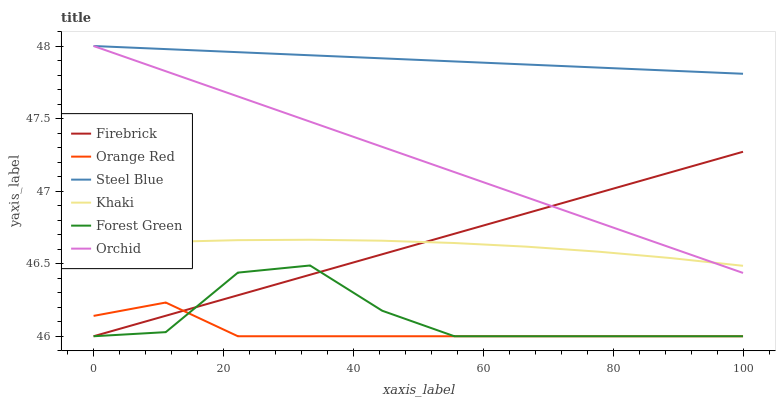Does Orange Red have the minimum area under the curve?
Answer yes or no. Yes. Does Steel Blue have the maximum area under the curve?
Answer yes or no. Yes. Does Firebrick have the minimum area under the curve?
Answer yes or no. No. Does Firebrick have the maximum area under the curve?
Answer yes or no. No. Is Orchid the smoothest?
Answer yes or no. Yes. Is Forest Green the roughest?
Answer yes or no. Yes. Is Firebrick the smoothest?
Answer yes or no. No. Is Firebrick the roughest?
Answer yes or no. No. Does Firebrick have the lowest value?
Answer yes or no. Yes. Does Steel Blue have the lowest value?
Answer yes or no. No. Does Orchid have the highest value?
Answer yes or no. Yes. Does Firebrick have the highest value?
Answer yes or no. No. Is Forest Green less than Steel Blue?
Answer yes or no. Yes. Is Orchid greater than Orange Red?
Answer yes or no. Yes. Does Khaki intersect Firebrick?
Answer yes or no. Yes. Is Khaki less than Firebrick?
Answer yes or no. No. Is Khaki greater than Firebrick?
Answer yes or no. No. Does Forest Green intersect Steel Blue?
Answer yes or no. No. 